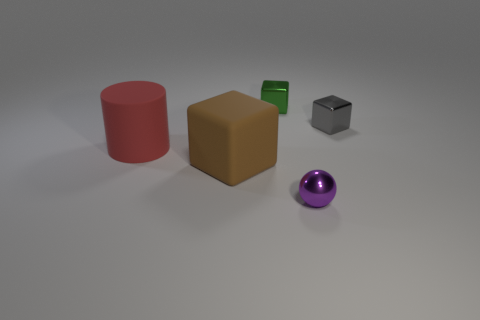Add 1 brown cubes. How many objects exist? 6 Subtract all cubes. How many objects are left? 2 Subtract all small cyan matte cubes. Subtract all small gray blocks. How many objects are left? 4 Add 5 metal things. How many metal things are left? 8 Add 4 cyan metallic spheres. How many cyan metallic spheres exist? 4 Subtract 0 purple cylinders. How many objects are left? 5 